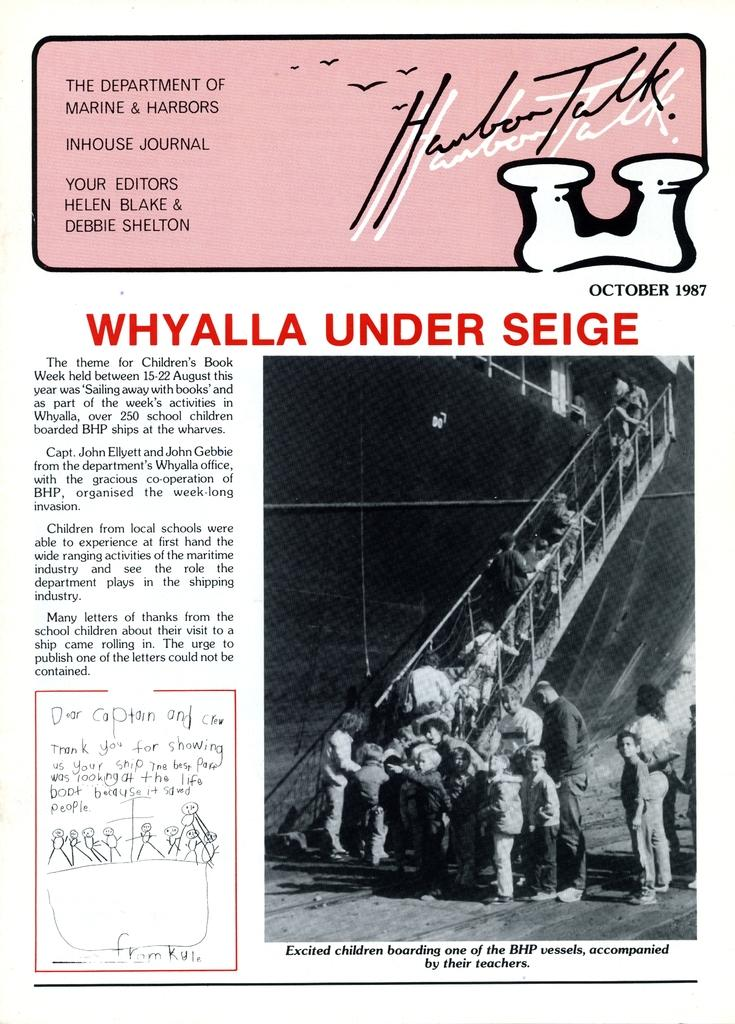<image>
Summarize the visual content of the image. whylla under seige flyer it looks old from while ago 